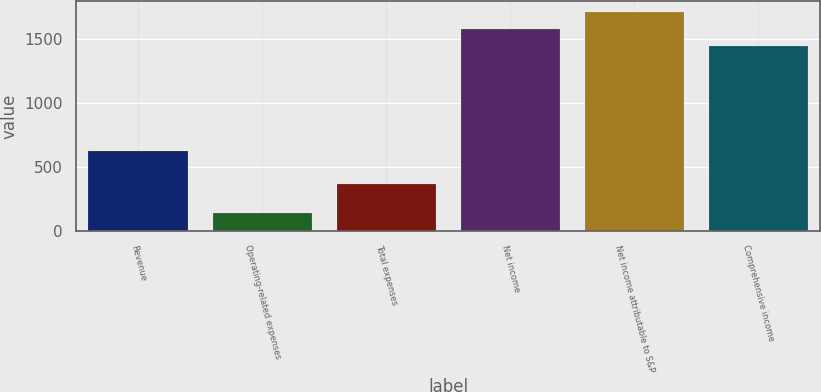<chart> <loc_0><loc_0><loc_500><loc_500><bar_chart><fcel>Revenue<fcel>Operating-related expenses<fcel>Total expenses<fcel>Net income<fcel>Net income attributable to S&P<fcel>Comprehensive income<nl><fcel>624<fcel>137<fcel>361<fcel>1577.2<fcel>1708.4<fcel>1446<nl></chart> 